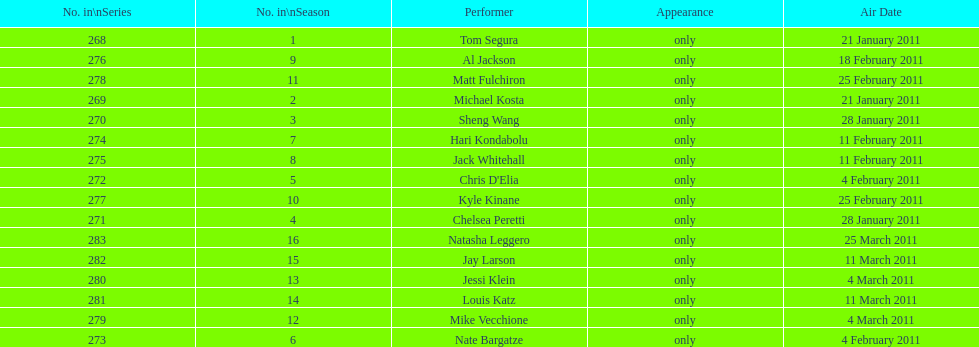Which month had the most performers? February. 